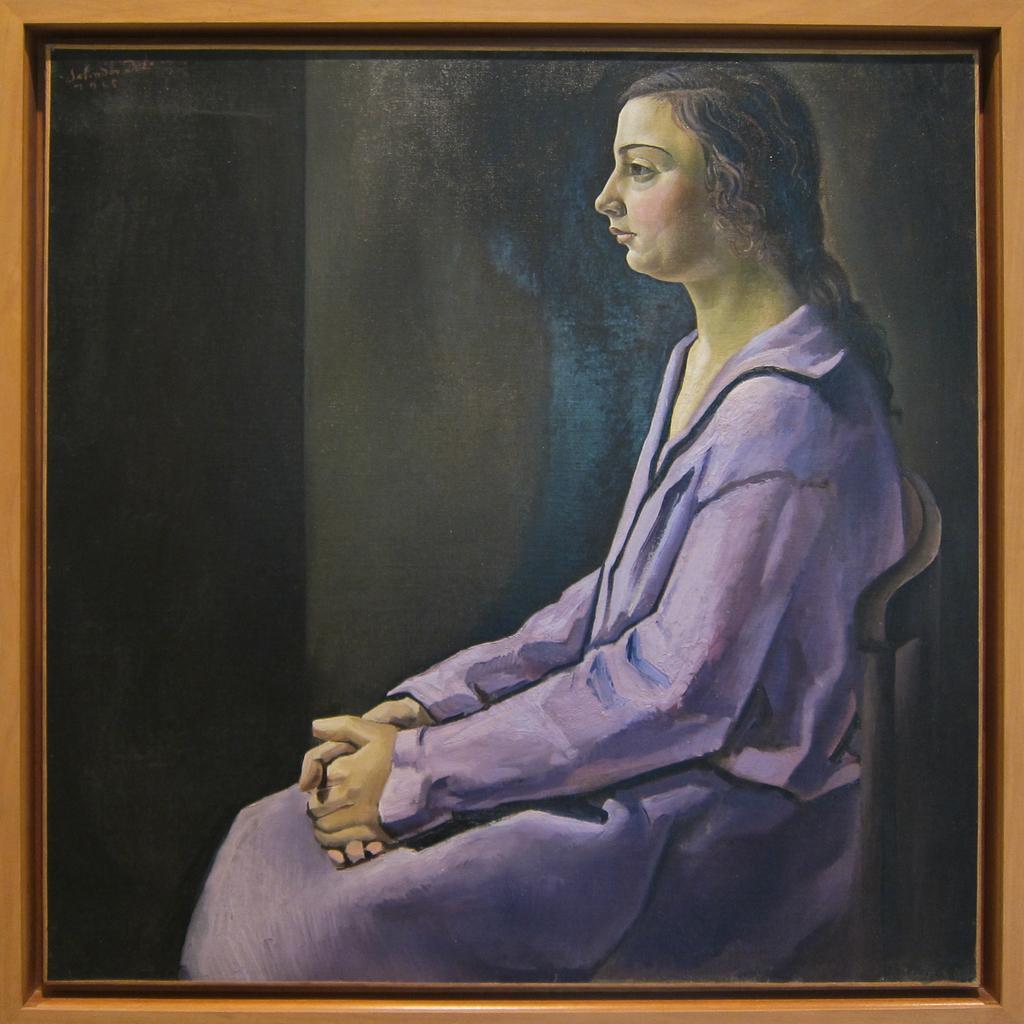In one or two sentences, can you explain what this image depicts? In this picture we can see the painting on this wooden box. In that painting we can see the woman who is wearing dress. She is sitting near the wall. 